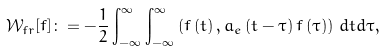Convert formula to latex. <formula><loc_0><loc_0><loc_500><loc_500>\mathcal { W } _ { f r } [ f ] \colon = - \frac { 1 } { 2 } \int _ { - \infty } ^ { \infty } \int _ { - \infty } ^ { \infty } \left ( f \left ( t \right ) , a _ { e } \left ( t - \tau \right ) f \left ( \tau \right ) \right ) \, d t d \tau ,</formula> 